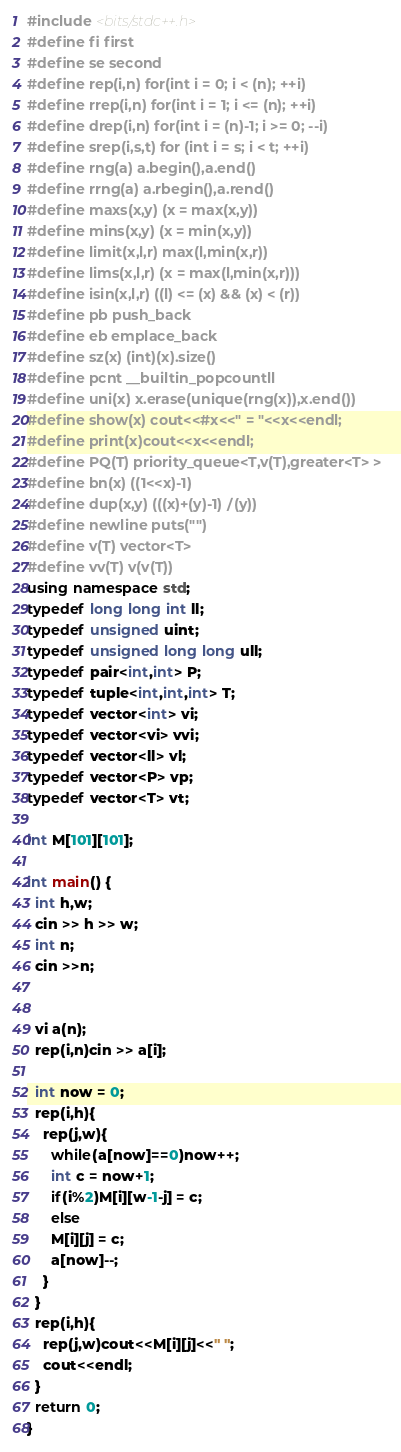Convert code to text. <code><loc_0><loc_0><loc_500><loc_500><_C++_>#include <bits/stdc++.h>
#define fi first
#define se second
#define rep(i,n) for(int i = 0; i < (n); ++i)
#define rrep(i,n) for(int i = 1; i <= (n); ++i)
#define drep(i,n) for(int i = (n)-1; i >= 0; --i)
#define srep(i,s,t) for (int i = s; i < t; ++i)
#define rng(a) a.begin(),a.end()
#define rrng(a) a.rbegin(),a.rend()
#define maxs(x,y) (x = max(x,y))
#define mins(x,y) (x = min(x,y))
#define limit(x,l,r) max(l,min(x,r))
#define lims(x,l,r) (x = max(l,min(x,r)))
#define isin(x,l,r) ((l) <= (x) && (x) < (r))
#define pb push_back
#define eb emplace_back
#define sz(x) (int)(x).size()
#define pcnt __builtin_popcountll
#define uni(x) x.erase(unique(rng(x)),x.end())
#define show(x) cout<<#x<<" = "<<x<<endl;
#define print(x)cout<<x<<endl;
#define PQ(T) priority_queue<T,v(T),greater<T> >
#define bn(x) ((1<<x)-1)
#define dup(x,y) (((x)+(y)-1)/(y))
#define newline puts("")
#define v(T) vector<T>
#define vv(T) v(v(T))
using namespace std;
typedef long long int ll;
typedef unsigned uint;
typedef unsigned long long ull;
typedef pair<int,int> P;
typedef tuple<int,int,int> T;
typedef vector<int> vi;
typedef vector<vi> vvi;
typedef vector<ll> vl;
typedef vector<P> vp;
typedef vector<T> vt;

int M[101][101];

int main() {
  int h,w;
  cin >> h >> w;
  int n;
  cin >>n;
  
  
  vi a(n);
  rep(i,n)cin >> a[i];

  int now = 0;
  rep(i,h){
    rep(j,w){
      while(a[now]==0)now++;
      int c = now+1;
      if(i%2)M[i][w-1-j] = c;
      else 
      M[i][j] = c; 
      a[now]--;
    }
  }
  rep(i,h){
    rep(j,w)cout<<M[i][j]<<" ";
    cout<<endl;
  }
  return 0;
}</code> 